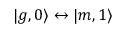Convert formula to latex. <formula><loc_0><loc_0><loc_500><loc_500>| g , 0 \rangle \leftrightarrow | m , 1 \rangle</formula> 